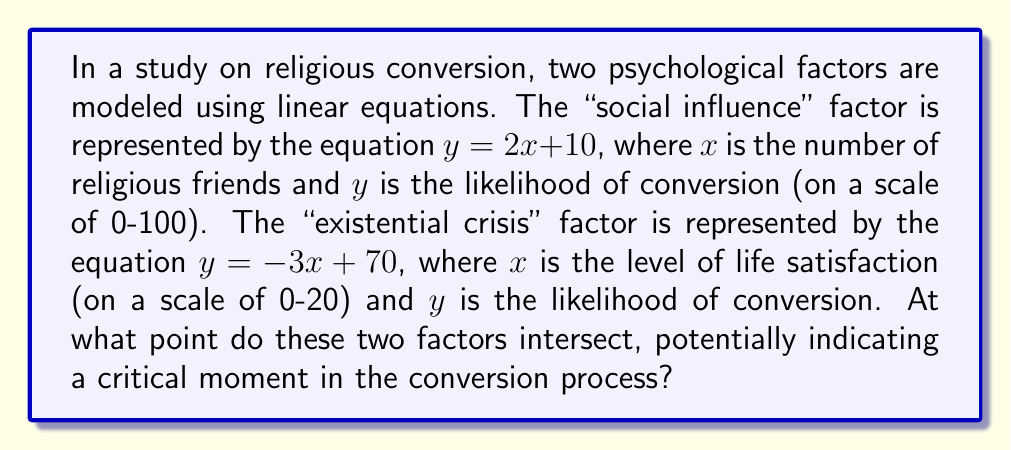Solve this math problem. To find the intersection point of these two linear equations, we need to solve them simultaneously:

1) Social influence equation: $y = 2x + 10$
2) Existential crisis equation: $y = -3x + 70$

At the intersection point, both equations will yield the same $y$ value. So we can set them equal to each other:

$$2x + 10 = -3x + 70$$

Now, let's solve for $x$:

$$2x + 3x = 70 - 10$$
$$5x = 60$$
$$x = 12$$

To find the corresponding $y$ value, we can substitute $x = 12$ into either of the original equations. Let's use the social influence equation:

$$y = 2(12) + 10 = 24 + 10 = 34$$

Therefore, the intersection point is $(12, 34)$.

In the context of our psychological factors:
- 12 represents both the number of religious friends and the level of life satisfaction.
- 34 represents the likelihood of conversion at this intersection point.
Answer: $(12, 34)$ 